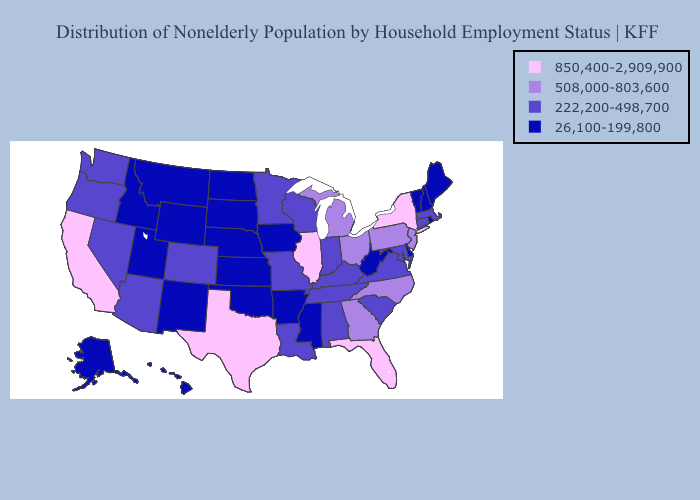Name the states that have a value in the range 850,400-2,909,900?
Short answer required. California, Florida, Illinois, New York, Texas. Among the states that border Alabama , which have the highest value?
Keep it brief. Florida. What is the highest value in the Northeast ?
Short answer required. 850,400-2,909,900. Name the states that have a value in the range 508,000-803,600?
Give a very brief answer. Georgia, Michigan, New Jersey, North Carolina, Ohio, Pennsylvania. How many symbols are there in the legend?
Give a very brief answer. 4. How many symbols are there in the legend?
Write a very short answer. 4. Name the states that have a value in the range 26,100-199,800?
Quick response, please. Alaska, Arkansas, Delaware, Hawaii, Idaho, Iowa, Kansas, Maine, Mississippi, Montana, Nebraska, New Hampshire, New Mexico, North Dakota, Oklahoma, Rhode Island, South Dakota, Utah, Vermont, West Virginia, Wyoming. How many symbols are there in the legend?
Quick response, please. 4. Which states hav the highest value in the Northeast?
Give a very brief answer. New York. Does the first symbol in the legend represent the smallest category?
Give a very brief answer. No. Does Delaware have a lower value than Pennsylvania?
Quick response, please. Yes. What is the value of Alabama?
Short answer required. 222,200-498,700. Does Nevada have a higher value than Tennessee?
Give a very brief answer. No. Which states have the lowest value in the USA?
Be succinct. Alaska, Arkansas, Delaware, Hawaii, Idaho, Iowa, Kansas, Maine, Mississippi, Montana, Nebraska, New Hampshire, New Mexico, North Dakota, Oklahoma, Rhode Island, South Dakota, Utah, Vermont, West Virginia, Wyoming. Among the states that border South Dakota , which have the highest value?
Keep it brief. Minnesota. 